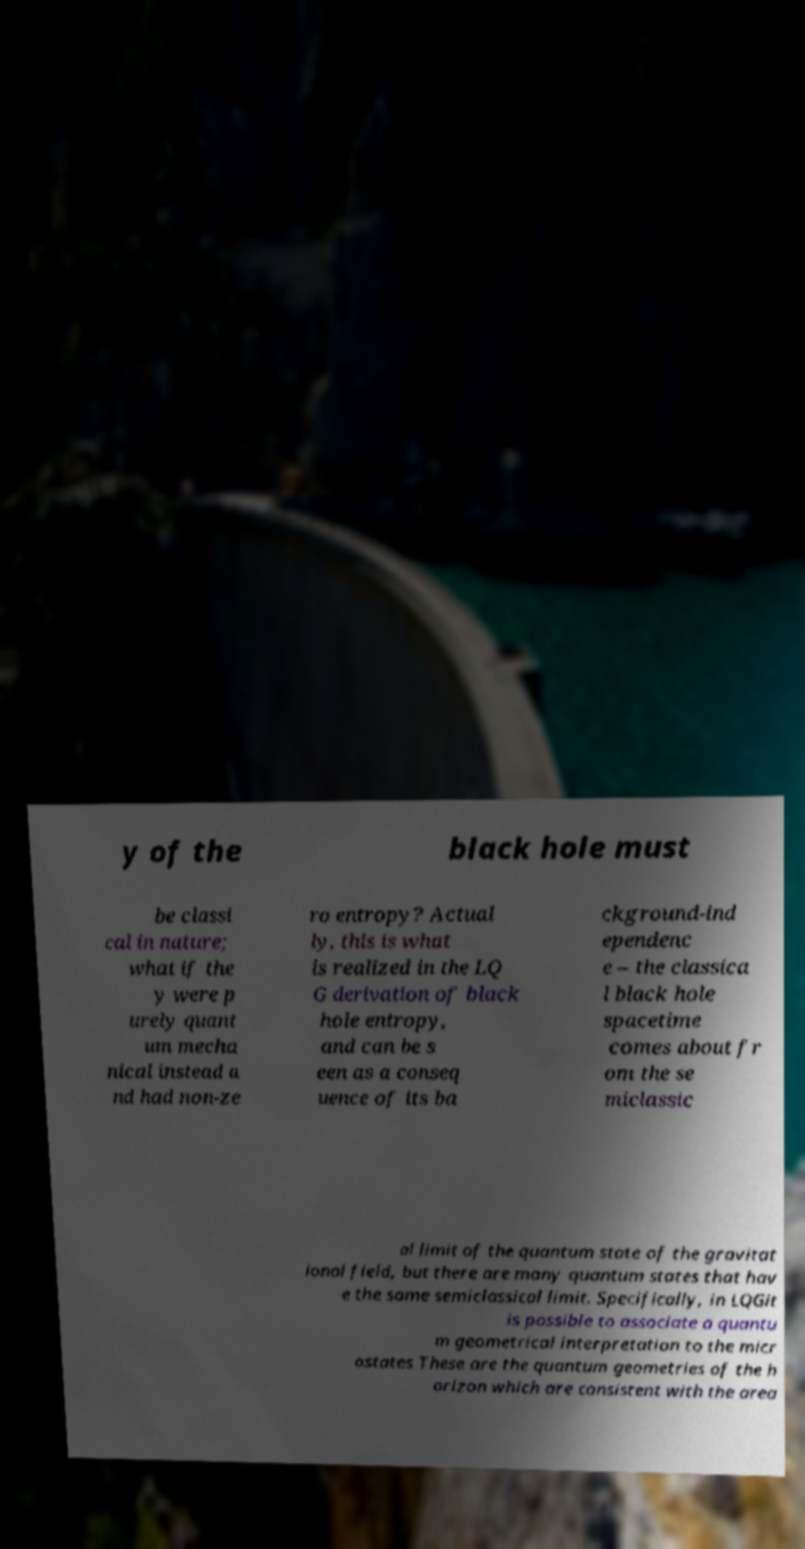What messages or text are displayed in this image? I need them in a readable, typed format. y of the black hole must be classi cal in nature; what if the y were p urely quant um mecha nical instead a nd had non-ze ro entropy? Actual ly, this is what is realized in the LQ G derivation of black hole entropy, and can be s een as a conseq uence of its ba ckground-ind ependenc e – the classica l black hole spacetime comes about fr om the se miclassic al limit of the quantum state of the gravitat ional field, but there are many quantum states that hav e the same semiclassical limit. Specifically, in LQGit is possible to associate a quantu m geometrical interpretation to the micr ostates These are the quantum geometries of the h orizon which are consistent with the area 